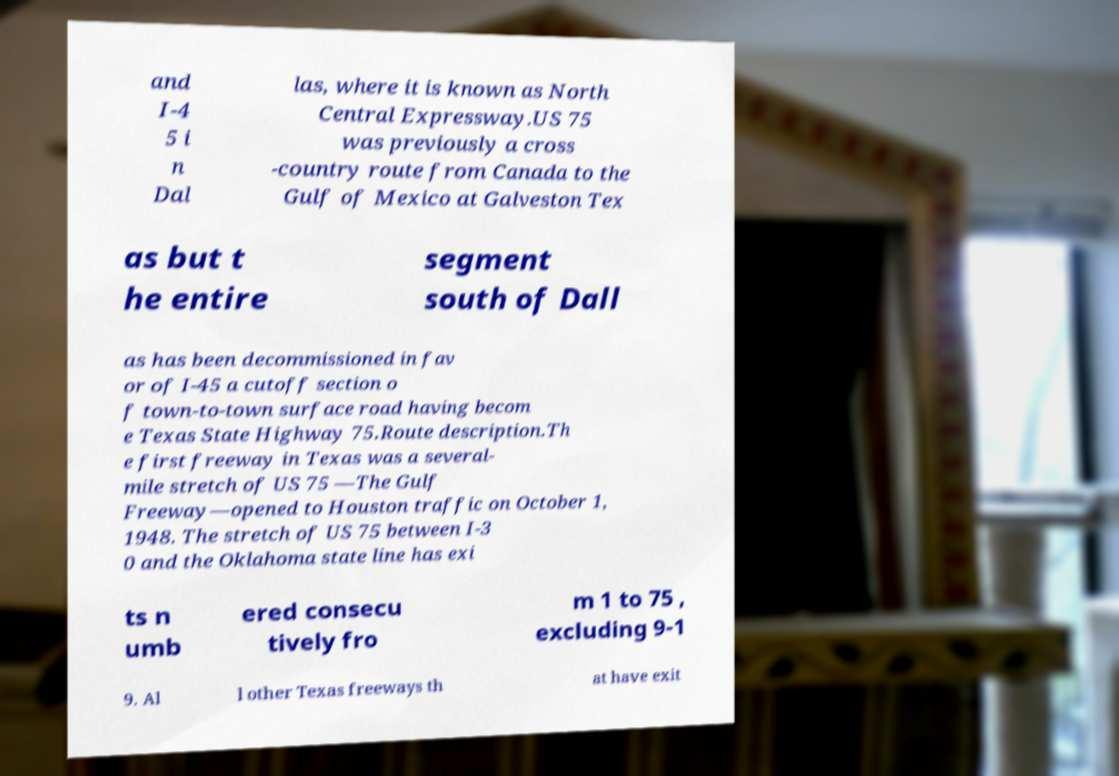For documentation purposes, I need the text within this image transcribed. Could you provide that? and I-4 5 i n Dal las, where it is known as North Central Expressway.US 75 was previously a cross -country route from Canada to the Gulf of Mexico at Galveston Tex as but t he entire segment south of Dall as has been decommissioned in fav or of I-45 a cutoff section o f town-to-town surface road having becom e Texas State Highway 75.Route description.Th e first freeway in Texas was a several- mile stretch of US 75 —The Gulf Freeway—opened to Houston traffic on October 1, 1948. The stretch of US 75 between I-3 0 and the Oklahoma state line has exi ts n umb ered consecu tively fro m 1 to 75 , excluding 9-1 9. Al l other Texas freeways th at have exit 